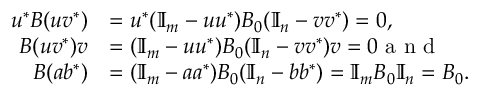Convert formula to latex. <formula><loc_0><loc_0><loc_500><loc_500>\begin{array} { r l } { u ^ { \ast } B ( u v ^ { \ast } ) } & { = u ^ { \ast } ( \mathbb { I } _ { m } - u u ^ { \ast } ) B _ { 0 } ( \mathbb { I } _ { n } - v v ^ { \ast } ) = 0 , } \\ { B ( u v ^ { \ast } ) v } & { = ( \mathbb { I } _ { m } - u u ^ { \ast } ) B _ { 0 } ( \mathbb { I } _ { n } - v v ^ { \ast } ) v = 0 a n d } \\ { B ( a b ^ { \ast } ) } & { = ( \mathbb { I } _ { m } - a a ^ { \ast } ) B _ { 0 } ( \mathbb { I } _ { n } - b b ^ { \ast } ) = \mathbb { I } _ { m } B _ { 0 } \mathbb { I } _ { n } = B _ { 0 } . } \end{array}</formula> 